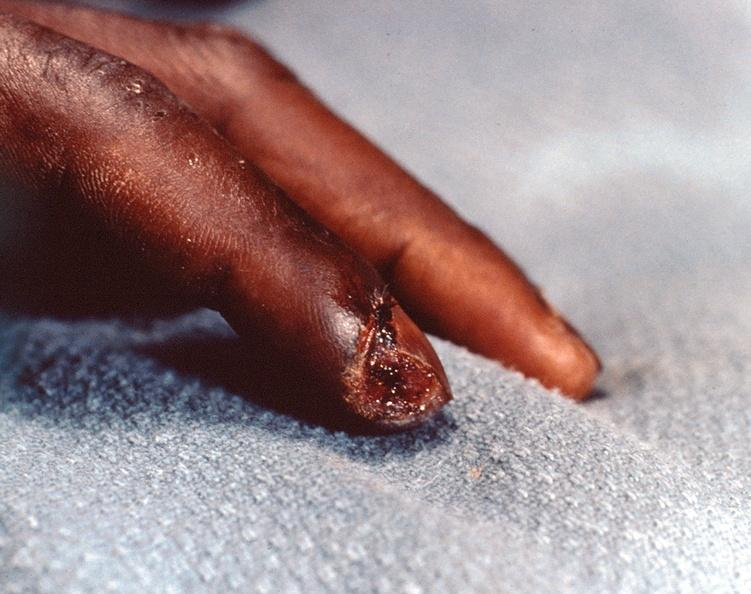what streptococcus a scepticemia in a patient with scleroderma who was on high dose steroids?
Answer the question using a single word or phrase. Necrosis of distal finger panniculitis and fascitis 